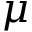Convert formula to latex. <formula><loc_0><loc_0><loc_500><loc_500>\mu</formula> 